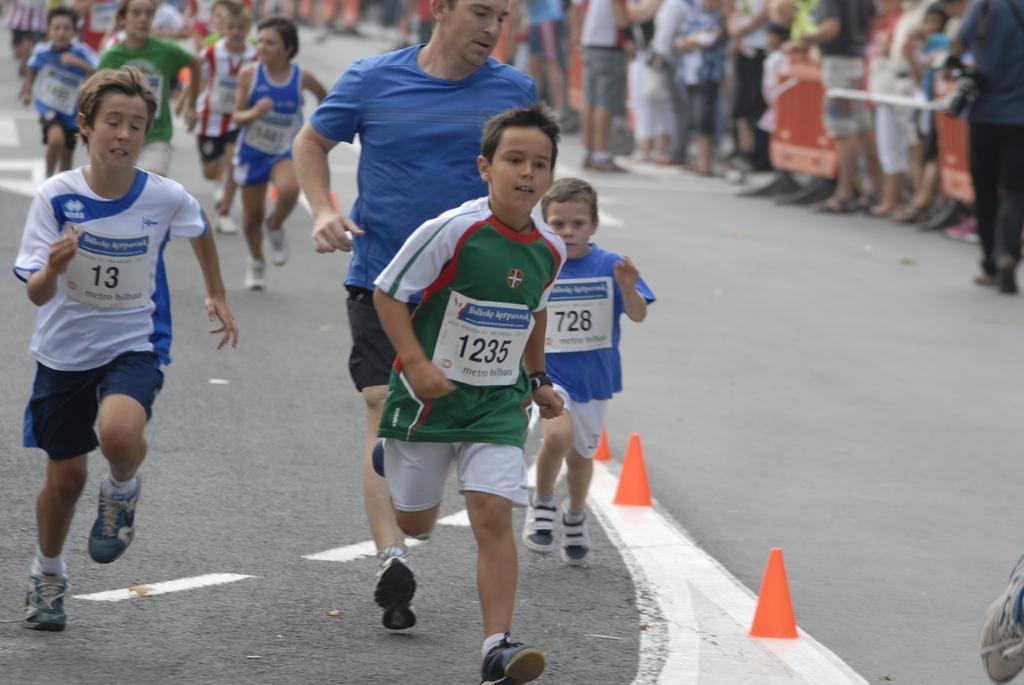Can you describe this image briefly? In the center of the image we can see a group of people running on the road. On the right side of the image we can see group of people standing. 